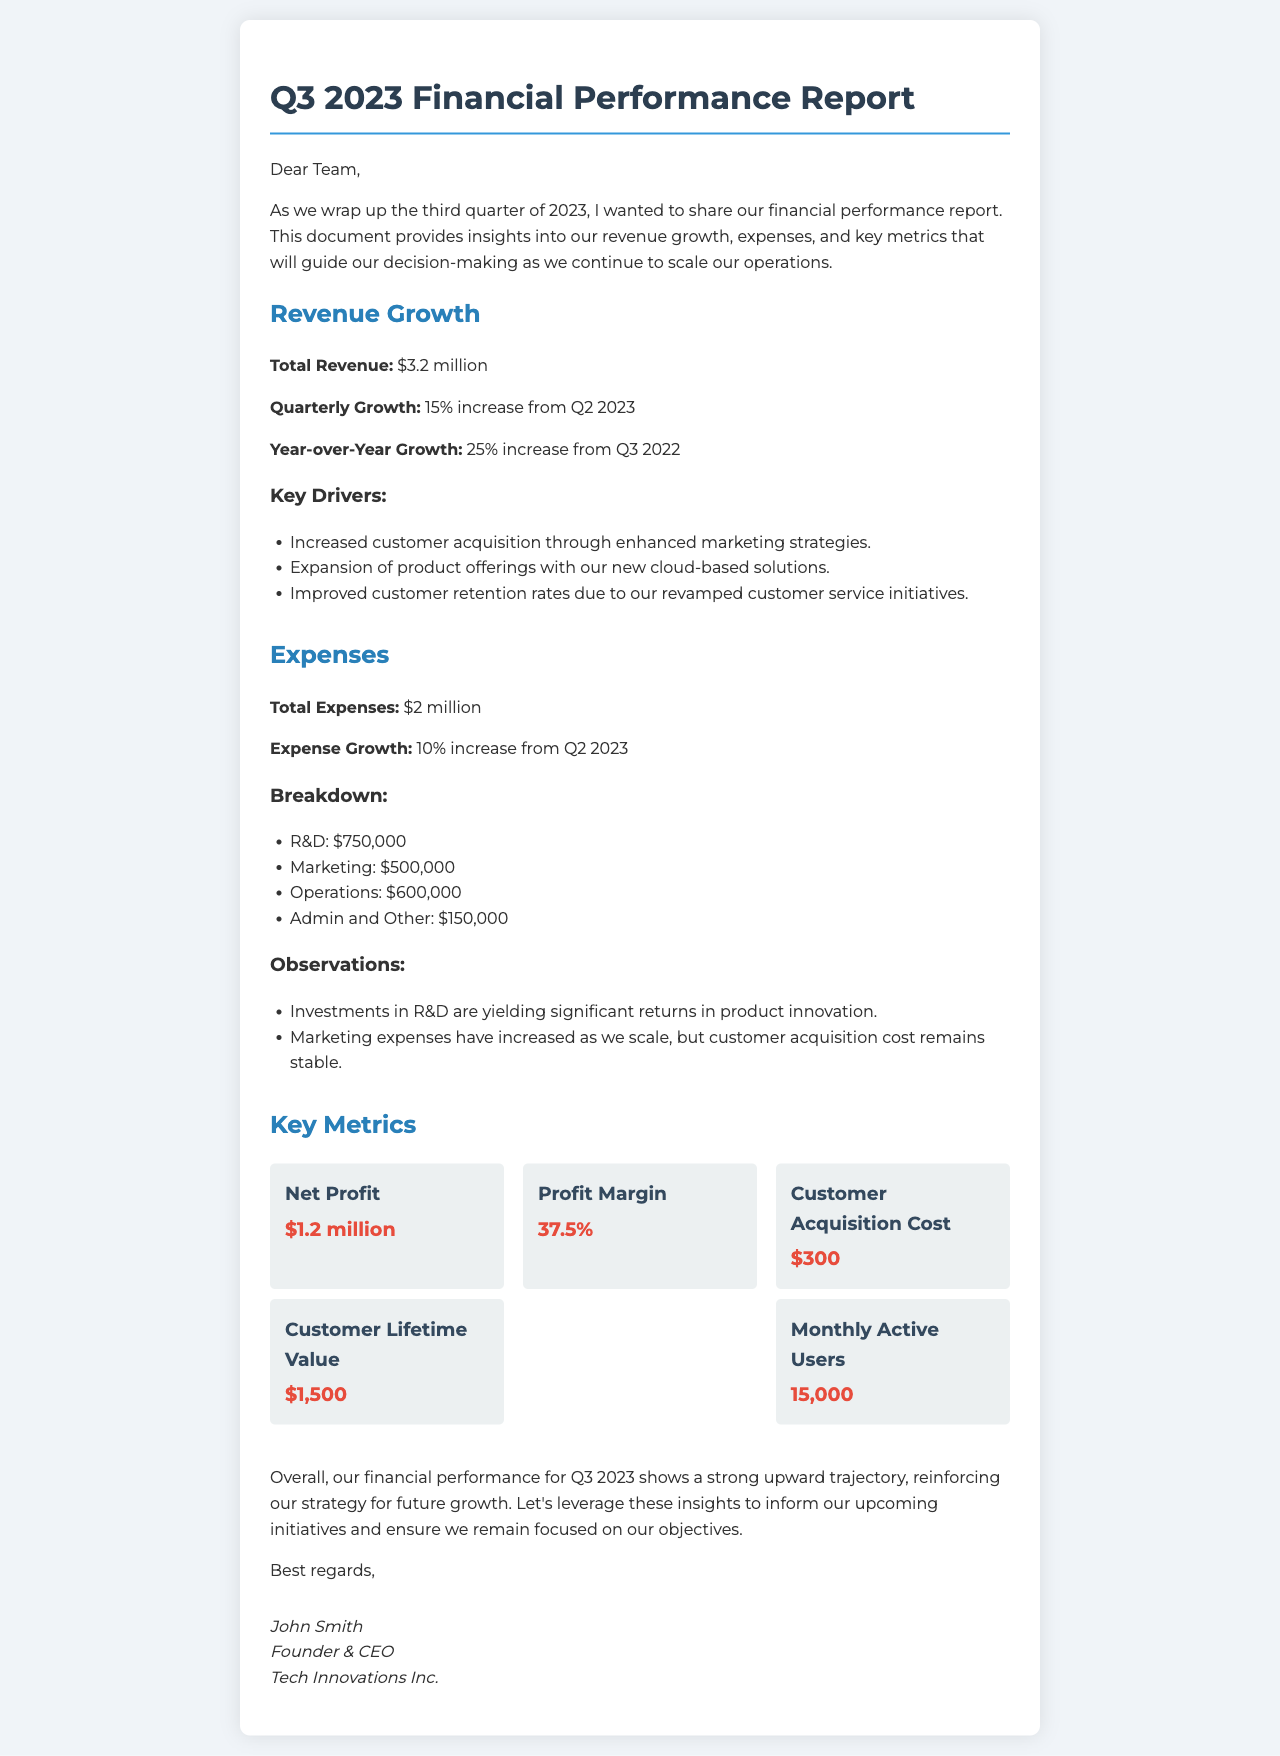What is the total revenue? The total revenue for Q3 2023 is listed in the document as $3.2 million.
Answer: $3.2 million What was the quarterly growth percentage? The document states that the quarterly growth is a 15% increase from Q2 2023.
Answer: 15% What are the total expenses? Total expenses for Q3 2023 are specified as $2 million in the document.
Answer: $2 million What is the profit margin? According to the document, the profit margin is calculated as 37.5%.
Answer: 37.5% What was invested in R&D? The document specifies that $750,000 was allocated for R&D expenses.
Answer: $750,000 What is the customer acquisition cost? The document lists the customer acquisition cost as $300.
Answer: $300 What is the monthly active users count? The number of monthly active users reported in the document is 15,000.
Answer: 15,000 What year-over-year growth percentage is mentioned? The year-over-year growth is detailed in the document as a 25% increase from Q3 2022.
Answer: 25% What is the signature of the sender? The sender's signature includes the name John Smith, along with his title and company name.
Answer: John Smith, Founder & CEO, Tech Innovations Inc 